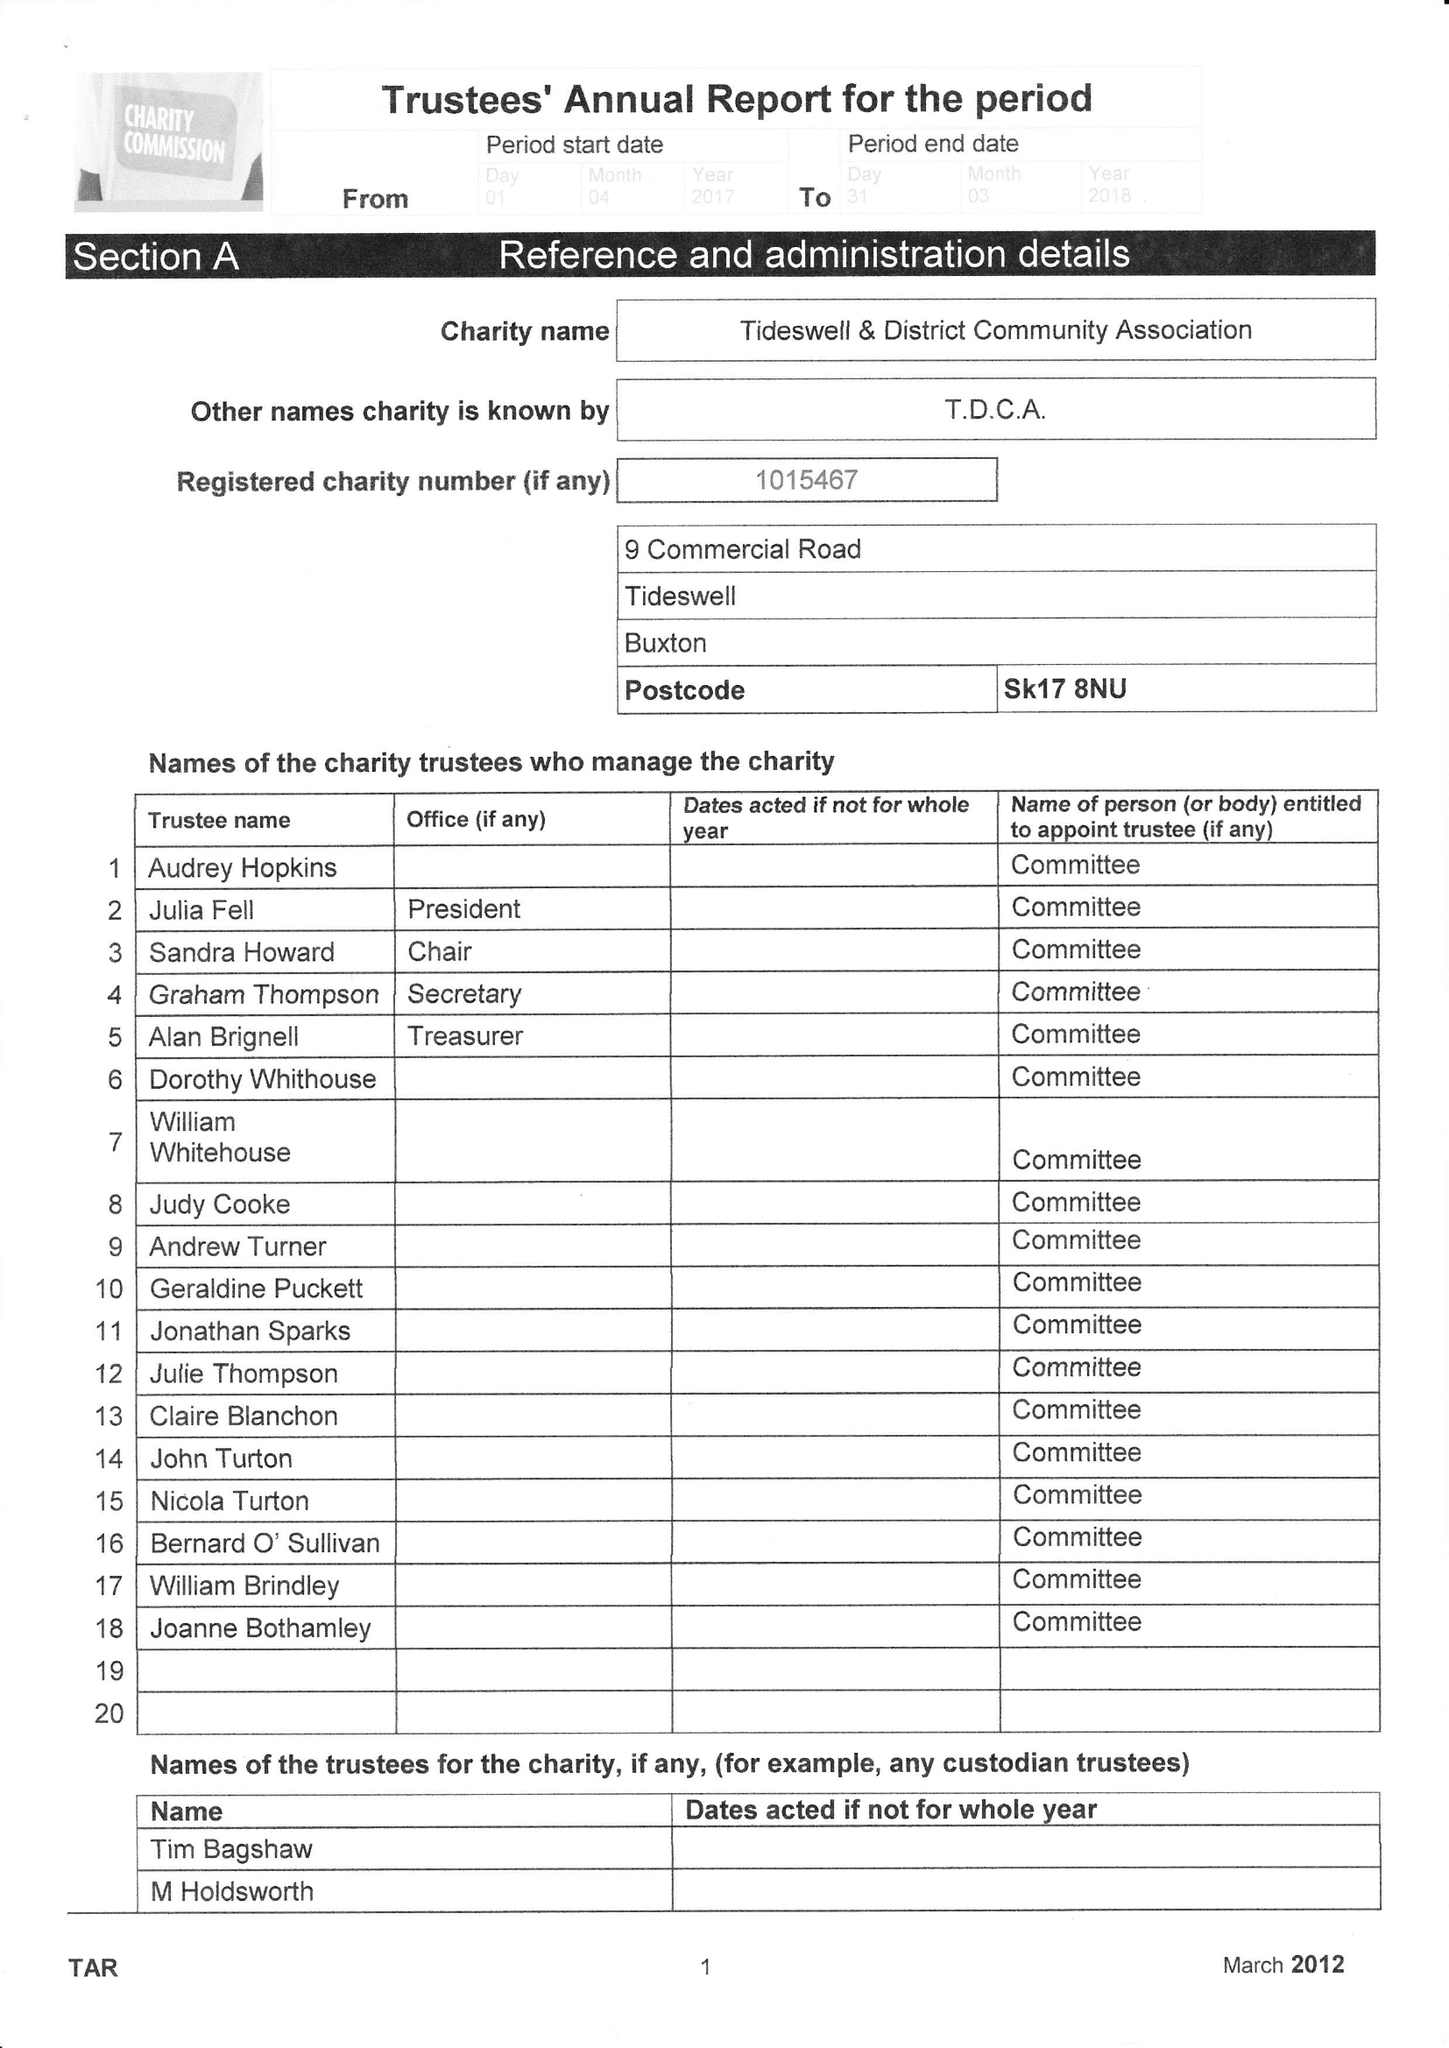What is the value for the spending_annually_in_british_pounds?
Answer the question using a single word or phrase. 20094.00 